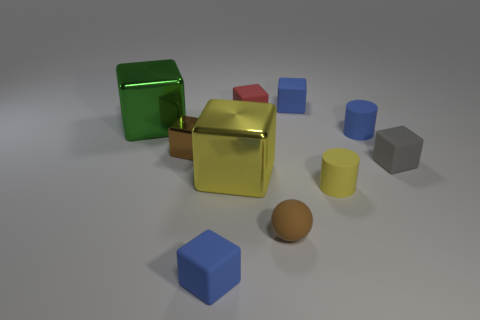How many blue blocks must be subtracted to get 1 blue blocks? 1 Subtract 1 blocks. How many blocks are left? 6 Subtract all tiny red rubber cubes. How many cubes are left? 6 Subtract all yellow cubes. How many cubes are left? 6 Subtract all red blocks. Subtract all yellow spheres. How many blocks are left? 6 Subtract all cylinders. How many objects are left? 8 Add 3 small matte blocks. How many small matte blocks are left? 7 Add 6 small yellow metal objects. How many small yellow metal objects exist? 6 Subtract 1 yellow cubes. How many objects are left? 9 Subtract all matte blocks. Subtract all yellow objects. How many objects are left? 4 